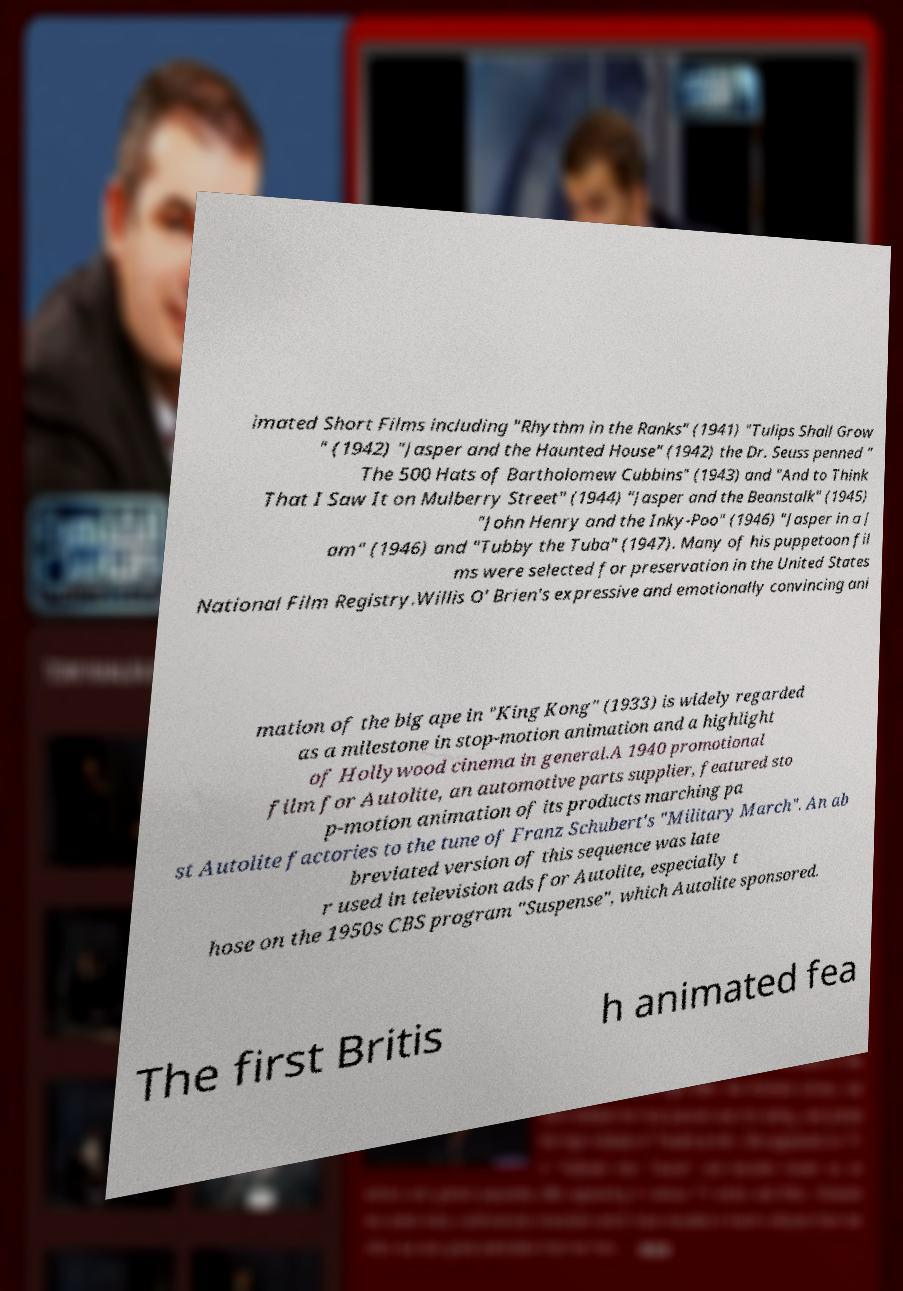Could you extract and type out the text from this image? imated Short Films including "Rhythm in the Ranks" (1941) "Tulips Shall Grow " (1942) "Jasper and the Haunted House" (1942) the Dr. Seuss penned " The 500 Hats of Bartholomew Cubbins" (1943) and "And to Think That I Saw It on Mulberry Street" (1944) "Jasper and the Beanstalk" (1945) "John Henry and the Inky-Poo" (1946) "Jasper in a J am" (1946) and "Tubby the Tuba" (1947). Many of his puppetoon fil ms were selected for preservation in the United States National Film Registry.Willis O' Brien's expressive and emotionally convincing ani mation of the big ape in "King Kong" (1933) is widely regarded as a milestone in stop-motion animation and a highlight of Hollywood cinema in general.A 1940 promotional film for Autolite, an automotive parts supplier, featured sto p-motion animation of its products marching pa st Autolite factories to the tune of Franz Schubert's "Military March". An ab breviated version of this sequence was late r used in television ads for Autolite, especially t hose on the 1950s CBS program "Suspense", which Autolite sponsored. The first Britis h animated fea 